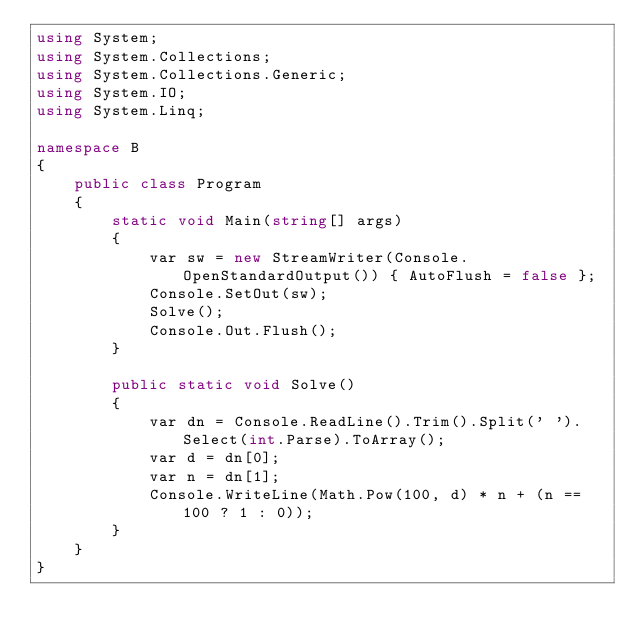<code> <loc_0><loc_0><loc_500><loc_500><_C#_>using System;
using System.Collections;
using System.Collections.Generic;
using System.IO;
using System.Linq;

namespace B
{
    public class Program
    {
        static void Main(string[] args)
        {
            var sw = new StreamWriter(Console.OpenStandardOutput()) { AutoFlush = false };
            Console.SetOut(sw);
            Solve();
            Console.Out.Flush();
        }

        public static void Solve()
        {
            var dn = Console.ReadLine().Trim().Split(' ').Select(int.Parse).ToArray();
            var d = dn[0];
            var n = dn[1];
            Console.WriteLine(Math.Pow(100, d) * n + (n == 100 ? 1 : 0));
        }
    }
}
</code> 